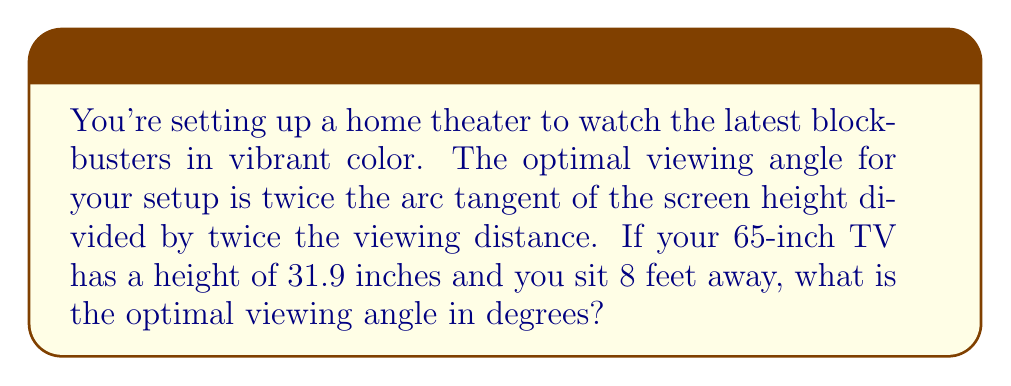Provide a solution to this math problem. Let's approach this step-by-step:

1) First, we need to convert the viewing distance from feet to inches:
   8 feet = 8 * 12 = 96 inches

2) We're given that the screen height is 31.9 inches.

3) The formula for the optimal viewing angle is:
   $$ \text{Optimal Angle} = 2 \cdot \arctan\left(\frac{h}{2d}\right) $$
   Where $h$ is the screen height and $d$ is the viewing distance.

4) Let's substitute our values:
   $$ \text{Optimal Angle} = 2 \cdot \arctan\left(\frac{31.9}{2 \cdot 96}\right) $$

5) Simplify inside the parentheses:
   $$ \text{Optimal Angle} = 2 \cdot \arctan\left(\frac{31.9}{192}\right) $$

6) Calculate the fraction:
   $$ \text{Optimal Angle} = 2 \cdot \arctan(0.16614583) $$

7) Calculate the arctan:
   $$ \text{Optimal Angle} = 2 \cdot 0.16465208 $$

8) Multiply:
   $$ \text{Optimal Angle} = 0.32930416 \text{ radians} $$

9) Convert to degrees:
   $$ \text{Optimal Angle} = 0.32930416 \cdot \frac{180}{\pi} = 18.86° $$

10) Round to two decimal places:
    $$ \text{Optimal Angle} \approx 18.86° $$
Answer: 18.86° 